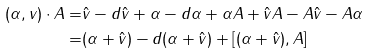Convert formula to latex. <formula><loc_0><loc_0><loc_500><loc_500>( \alpha , v ) \cdot A = & \hat { v } - d \hat { v } + \alpha - d \alpha + \alpha A + \hat { v } A - A \hat { v } - A \alpha \\ = & ( \alpha + \hat { v } ) - d ( \alpha + \hat { v } ) + [ ( \alpha + \hat { v } ) , A ]</formula> 